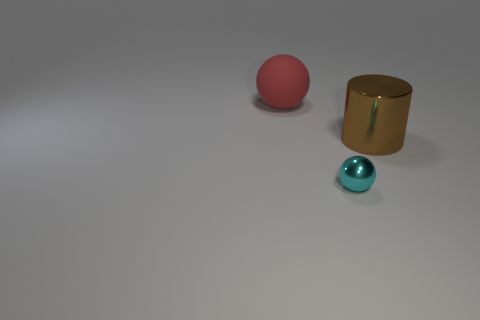Is there any other thing that has the same size as the cyan ball?
Offer a terse response. No. Do the metallic thing that is behind the tiny cyan metallic ball and the shiny thing that is on the left side of the big metallic object have the same shape?
Keep it short and to the point. No. How many things are either large gray objects or balls that are right of the big red matte ball?
Ensure brevity in your answer.  1. What number of cyan metallic balls are the same size as the red object?
Give a very brief answer. 0. What number of gray objects are small matte cylinders or balls?
Offer a terse response. 0. What shape is the big thing on the right side of the big thing left of the cyan shiny ball?
Provide a succinct answer. Cylinder. What shape is the red object that is the same size as the metallic cylinder?
Keep it short and to the point. Sphere. Is there a tiny metal sphere of the same color as the large rubber sphere?
Make the answer very short. No. Are there the same number of big brown objects that are behind the shiny cylinder and tiny spheres that are on the left side of the small cyan ball?
Offer a very short reply. Yes. There is a tiny cyan metal thing; does it have the same shape as the big object left of the brown cylinder?
Give a very brief answer. Yes. 